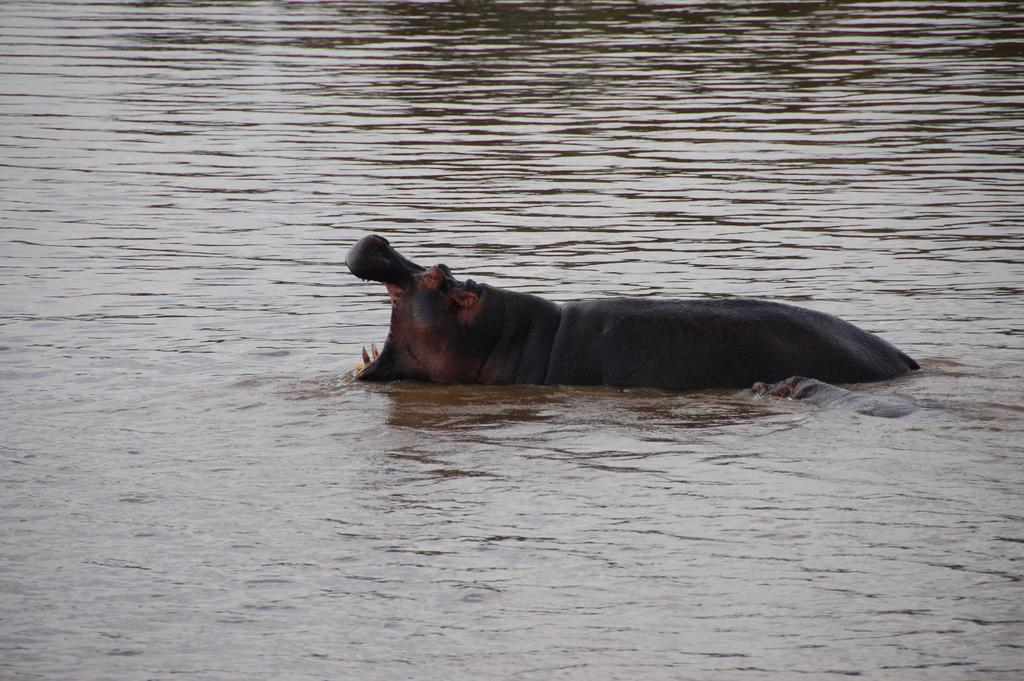What animal is in the image? There is a hippopotamus in the image. Where is the hippopotamus located? The hippopotamus is in the water. What is the hippopotamus doing in the image? The hippopotamus's mouth is wide open. What else can be seen in the image besides the hippopotamus? There is water visible in the image. What type of playground equipment can be seen in the image? There is no playground equipment present in the image; it features a hippopotamus in the water. What color is the hippopotamus's skin in the image? The color of the hippopotamus's skin cannot be determined from the image, as it is underwater. 